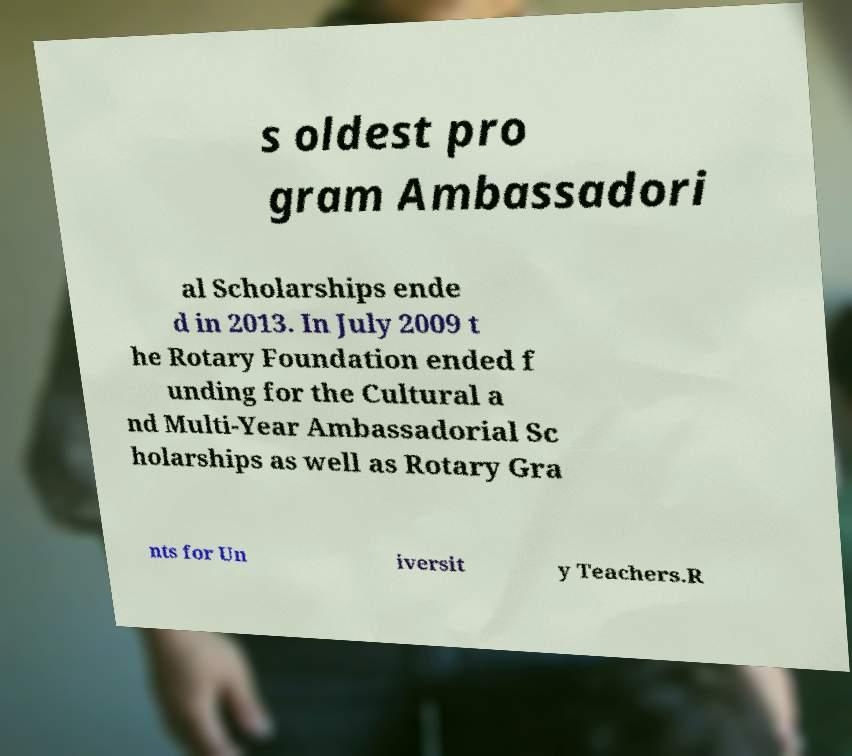Can you accurately transcribe the text from the provided image for me? s oldest pro gram Ambassadori al Scholarships ende d in 2013. In July 2009 t he Rotary Foundation ended f unding for the Cultural a nd Multi-Year Ambassadorial Sc holarships as well as Rotary Gra nts for Un iversit y Teachers.R 